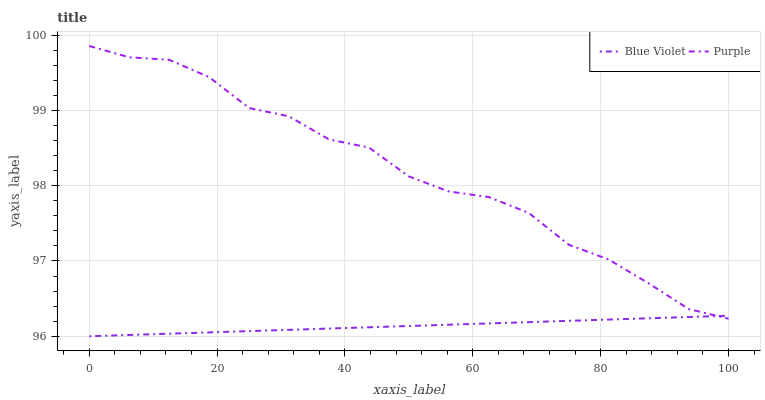Does Blue Violet have the minimum area under the curve?
Answer yes or no. Yes. Does Purple have the maximum area under the curve?
Answer yes or no. Yes. Does Blue Violet have the maximum area under the curve?
Answer yes or no. No. Is Blue Violet the smoothest?
Answer yes or no. Yes. Is Purple the roughest?
Answer yes or no. Yes. Is Blue Violet the roughest?
Answer yes or no. No. Does Blue Violet have the highest value?
Answer yes or no. No. 